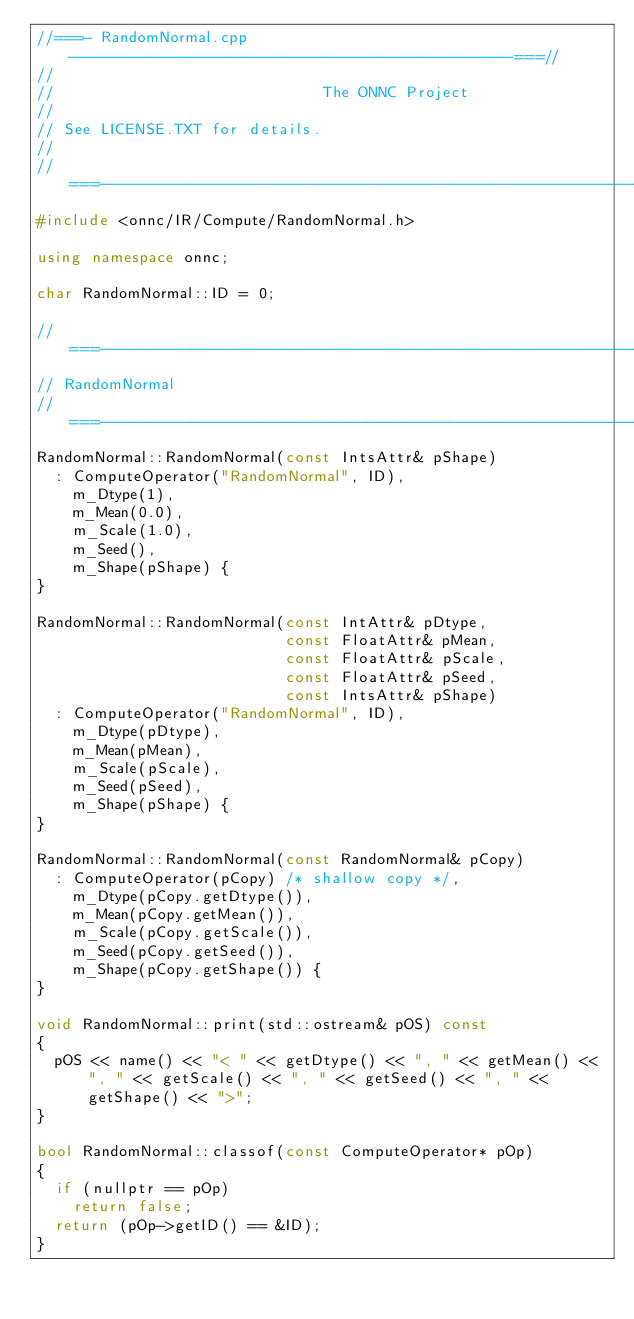Convert code to text. <code><loc_0><loc_0><loc_500><loc_500><_C++_>//===- RandomNormal.cpp ------------------------------------------------===//
//
//                             The ONNC Project
//
// See LICENSE.TXT for details.
//
//===----------------------------------------------------------------------===//
#include <onnc/IR/Compute/RandomNormal.h>

using namespace onnc;

char RandomNormal::ID = 0;

//===----------------------------------------------------------------------===//
// RandomNormal
//===----------------------------------------------------------------------===//
RandomNormal::RandomNormal(const IntsAttr& pShape)
  : ComputeOperator("RandomNormal", ID),
    m_Dtype(1),
    m_Mean(0.0),
    m_Scale(1.0),
    m_Seed(),
    m_Shape(pShape) {
}

RandomNormal::RandomNormal(const IntAttr& pDtype,
                           const FloatAttr& pMean,
                           const FloatAttr& pScale,
                           const FloatAttr& pSeed,
                           const IntsAttr& pShape)
  : ComputeOperator("RandomNormal", ID),
    m_Dtype(pDtype),
    m_Mean(pMean),
    m_Scale(pScale),
    m_Seed(pSeed),
    m_Shape(pShape) {
}

RandomNormal::RandomNormal(const RandomNormal& pCopy)
  : ComputeOperator(pCopy) /* shallow copy */,
    m_Dtype(pCopy.getDtype()),
    m_Mean(pCopy.getMean()),
    m_Scale(pCopy.getScale()),
    m_Seed(pCopy.getSeed()),
    m_Shape(pCopy.getShape()) {
}

void RandomNormal::print(std::ostream& pOS) const
{
  pOS << name() << "< " << getDtype() << ", " << getMean() << ", " << getScale() << ", " << getSeed() << ", " << getShape() << ">";
}

bool RandomNormal::classof(const ComputeOperator* pOp)
{
  if (nullptr == pOp)
    return false;
  return (pOp->getID() == &ID);
}
</code> 